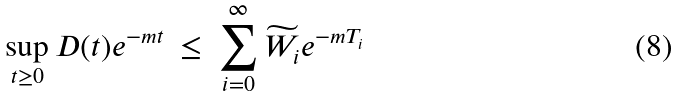Convert formula to latex. <formula><loc_0><loc_0><loc_500><loc_500>\sup _ { t \geq 0 } D ( t ) e ^ { - m t } \ \leq \ \sum _ { i = 0 } ^ { \infty } \widetilde { W } _ { i } e ^ { - m T _ { i } }</formula> 